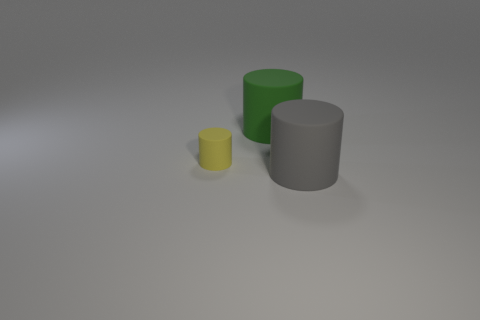Are the cylinders arranged in any particular pattern? The cylinders are arranged in a descending order of size from right to left with the largest being the gray one. There doesn't seem to be a precise pattern, but their linear arrangement might suggest an intention to compare their sizes or colors. How does their arrangement affect the composition of the image? The composition presents a clear gradient in size, creating a sense of depth and perspective. The varying heights and colors lead the viewer's eye across the image, providing a simple yet effective visual interest. 